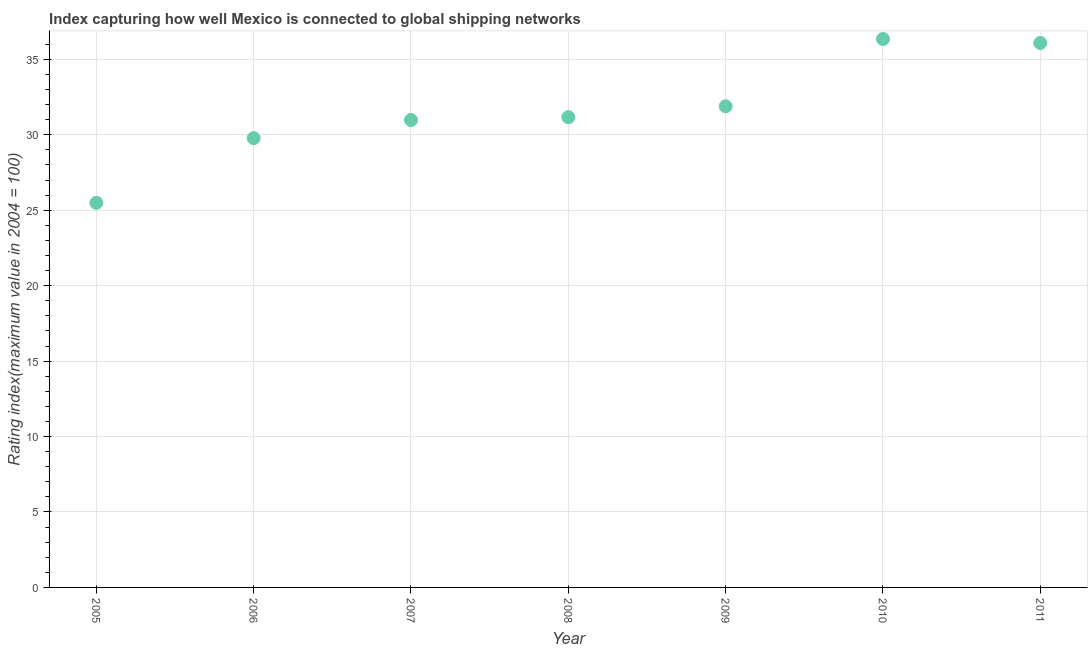What is the liner shipping connectivity index in 2008?
Ensure brevity in your answer.  31.17. Across all years, what is the maximum liner shipping connectivity index?
Offer a terse response. 36.35. Across all years, what is the minimum liner shipping connectivity index?
Provide a short and direct response. 25.49. In which year was the liner shipping connectivity index maximum?
Provide a short and direct response. 2010. In which year was the liner shipping connectivity index minimum?
Provide a short and direct response. 2005. What is the sum of the liner shipping connectivity index?
Offer a terse response. 221.75. What is the difference between the liner shipping connectivity index in 2006 and 2009?
Offer a terse response. -2.11. What is the average liner shipping connectivity index per year?
Provide a short and direct response. 31.68. What is the median liner shipping connectivity index?
Offer a very short reply. 31.17. What is the ratio of the liner shipping connectivity index in 2005 to that in 2006?
Make the answer very short. 0.86. Is the difference between the liner shipping connectivity index in 2008 and 2009 greater than the difference between any two years?
Keep it short and to the point. No. What is the difference between the highest and the second highest liner shipping connectivity index?
Make the answer very short. 0.26. Is the sum of the liner shipping connectivity index in 2006 and 2007 greater than the maximum liner shipping connectivity index across all years?
Your answer should be very brief. Yes. What is the difference between the highest and the lowest liner shipping connectivity index?
Ensure brevity in your answer.  10.86. In how many years, is the liner shipping connectivity index greater than the average liner shipping connectivity index taken over all years?
Make the answer very short. 3. Does the liner shipping connectivity index monotonically increase over the years?
Offer a terse response. No. How many years are there in the graph?
Offer a very short reply. 7. What is the difference between two consecutive major ticks on the Y-axis?
Keep it short and to the point. 5. Are the values on the major ticks of Y-axis written in scientific E-notation?
Provide a short and direct response. No. Does the graph contain any zero values?
Provide a succinct answer. No. Does the graph contain grids?
Provide a succinct answer. Yes. What is the title of the graph?
Offer a terse response. Index capturing how well Mexico is connected to global shipping networks. What is the label or title of the X-axis?
Provide a short and direct response. Year. What is the label or title of the Y-axis?
Give a very brief answer. Rating index(maximum value in 2004 = 100). What is the Rating index(maximum value in 2004 = 100) in 2005?
Offer a very short reply. 25.49. What is the Rating index(maximum value in 2004 = 100) in 2006?
Offer a terse response. 29.78. What is the Rating index(maximum value in 2004 = 100) in 2007?
Provide a short and direct response. 30.98. What is the Rating index(maximum value in 2004 = 100) in 2008?
Your response must be concise. 31.17. What is the Rating index(maximum value in 2004 = 100) in 2009?
Ensure brevity in your answer.  31.89. What is the Rating index(maximum value in 2004 = 100) in 2010?
Give a very brief answer. 36.35. What is the Rating index(maximum value in 2004 = 100) in 2011?
Your response must be concise. 36.09. What is the difference between the Rating index(maximum value in 2004 = 100) in 2005 and 2006?
Give a very brief answer. -4.29. What is the difference between the Rating index(maximum value in 2004 = 100) in 2005 and 2007?
Your response must be concise. -5.49. What is the difference between the Rating index(maximum value in 2004 = 100) in 2005 and 2008?
Give a very brief answer. -5.68. What is the difference between the Rating index(maximum value in 2004 = 100) in 2005 and 2009?
Keep it short and to the point. -6.4. What is the difference between the Rating index(maximum value in 2004 = 100) in 2005 and 2010?
Your answer should be very brief. -10.86. What is the difference between the Rating index(maximum value in 2004 = 100) in 2005 and 2011?
Make the answer very short. -10.6. What is the difference between the Rating index(maximum value in 2004 = 100) in 2006 and 2008?
Provide a short and direct response. -1.39. What is the difference between the Rating index(maximum value in 2004 = 100) in 2006 and 2009?
Offer a terse response. -2.11. What is the difference between the Rating index(maximum value in 2004 = 100) in 2006 and 2010?
Provide a short and direct response. -6.57. What is the difference between the Rating index(maximum value in 2004 = 100) in 2006 and 2011?
Make the answer very short. -6.31. What is the difference between the Rating index(maximum value in 2004 = 100) in 2007 and 2008?
Provide a short and direct response. -0.19. What is the difference between the Rating index(maximum value in 2004 = 100) in 2007 and 2009?
Provide a short and direct response. -0.91. What is the difference between the Rating index(maximum value in 2004 = 100) in 2007 and 2010?
Make the answer very short. -5.37. What is the difference between the Rating index(maximum value in 2004 = 100) in 2007 and 2011?
Provide a succinct answer. -5.11. What is the difference between the Rating index(maximum value in 2004 = 100) in 2008 and 2009?
Ensure brevity in your answer.  -0.72. What is the difference between the Rating index(maximum value in 2004 = 100) in 2008 and 2010?
Ensure brevity in your answer.  -5.18. What is the difference between the Rating index(maximum value in 2004 = 100) in 2008 and 2011?
Provide a succinct answer. -4.92. What is the difference between the Rating index(maximum value in 2004 = 100) in 2009 and 2010?
Make the answer very short. -4.46. What is the difference between the Rating index(maximum value in 2004 = 100) in 2010 and 2011?
Your answer should be very brief. 0.26. What is the ratio of the Rating index(maximum value in 2004 = 100) in 2005 to that in 2006?
Make the answer very short. 0.86. What is the ratio of the Rating index(maximum value in 2004 = 100) in 2005 to that in 2007?
Your answer should be very brief. 0.82. What is the ratio of the Rating index(maximum value in 2004 = 100) in 2005 to that in 2008?
Give a very brief answer. 0.82. What is the ratio of the Rating index(maximum value in 2004 = 100) in 2005 to that in 2009?
Keep it short and to the point. 0.8. What is the ratio of the Rating index(maximum value in 2004 = 100) in 2005 to that in 2010?
Your answer should be very brief. 0.7. What is the ratio of the Rating index(maximum value in 2004 = 100) in 2005 to that in 2011?
Your response must be concise. 0.71. What is the ratio of the Rating index(maximum value in 2004 = 100) in 2006 to that in 2007?
Your response must be concise. 0.96. What is the ratio of the Rating index(maximum value in 2004 = 100) in 2006 to that in 2008?
Give a very brief answer. 0.95. What is the ratio of the Rating index(maximum value in 2004 = 100) in 2006 to that in 2009?
Your answer should be compact. 0.93. What is the ratio of the Rating index(maximum value in 2004 = 100) in 2006 to that in 2010?
Keep it short and to the point. 0.82. What is the ratio of the Rating index(maximum value in 2004 = 100) in 2006 to that in 2011?
Your answer should be compact. 0.82. What is the ratio of the Rating index(maximum value in 2004 = 100) in 2007 to that in 2009?
Provide a succinct answer. 0.97. What is the ratio of the Rating index(maximum value in 2004 = 100) in 2007 to that in 2010?
Offer a terse response. 0.85. What is the ratio of the Rating index(maximum value in 2004 = 100) in 2007 to that in 2011?
Offer a very short reply. 0.86. What is the ratio of the Rating index(maximum value in 2004 = 100) in 2008 to that in 2009?
Give a very brief answer. 0.98. What is the ratio of the Rating index(maximum value in 2004 = 100) in 2008 to that in 2010?
Offer a very short reply. 0.86. What is the ratio of the Rating index(maximum value in 2004 = 100) in 2008 to that in 2011?
Make the answer very short. 0.86. What is the ratio of the Rating index(maximum value in 2004 = 100) in 2009 to that in 2010?
Your response must be concise. 0.88. What is the ratio of the Rating index(maximum value in 2004 = 100) in 2009 to that in 2011?
Your answer should be very brief. 0.88. 